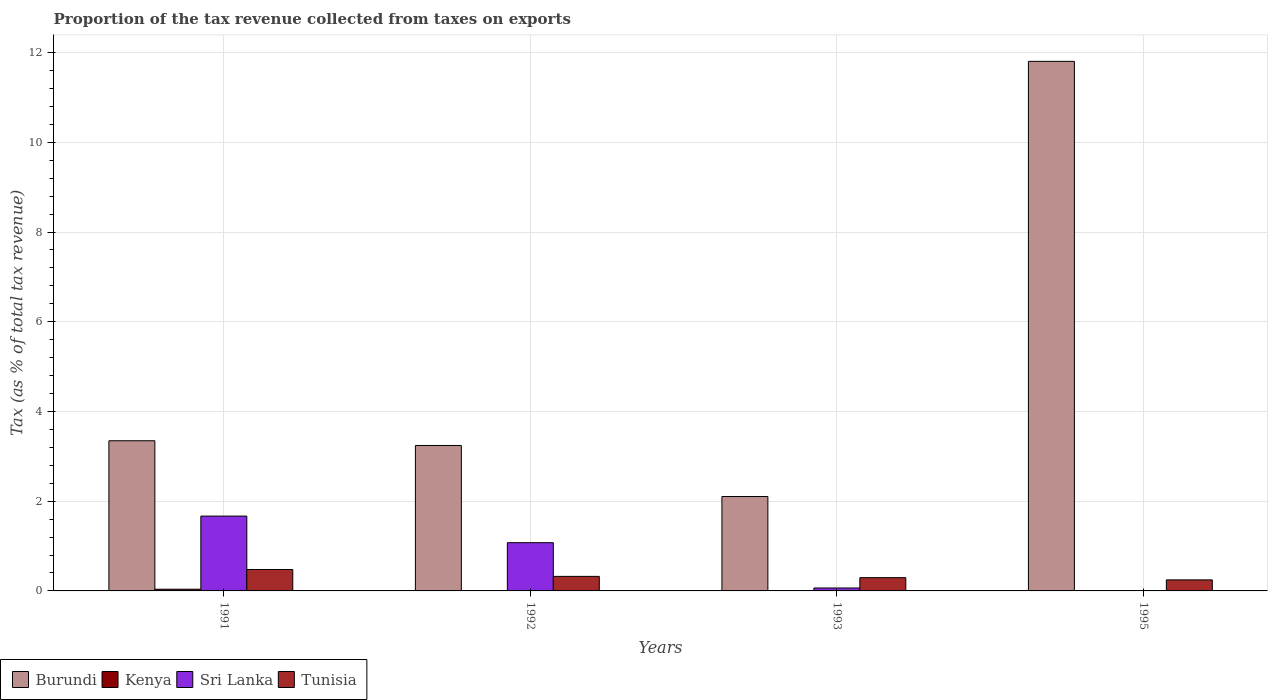How many different coloured bars are there?
Keep it short and to the point. 4. Are the number of bars per tick equal to the number of legend labels?
Provide a succinct answer. Yes. What is the label of the 1st group of bars from the left?
Keep it short and to the point. 1991. In how many cases, is the number of bars for a given year not equal to the number of legend labels?
Provide a short and direct response. 0. What is the proportion of the tax revenue collected in Burundi in 1991?
Your answer should be very brief. 3.35. Across all years, what is the maximum proportion of the tax revenue collected in Sri Lanka?
Your answer should be compact. 1.67. Across all years, what is the minimum proportion of the tax revenue collected in Kenya?
Your answer should be compact. 0. In which year was the proportion of the tax revenue collected in Sri Lanka minimum?
Your answer should be very brief. 1995. What is the total proportion of the tax revenue collected in Kenya in the graph?
Offer a very short reply. 0.05. What is the difference between the proportion of the tax revenue collected in Tunisia in 1993 and that in 1995?
Make the answer very short. 0.05. What is the difference between the proportion of the tax revenue collected in Kenya in 1992 and the proportion of the tax revenue collected in Burundi in 1993?
Offer a terse response. -2.1. What is the average proportion of the tax revenue collected in Burundi per year?
Give a very brief answer. 5.12. In the year 1995, what is the difference between the proportion of the tax revenue collected in Kenya and proportion of the tax revenue collected in Tunisia?
Offer a very short reply. -0.24. In how many years, is the proportion of the tax revenue collected in Sri Lanka greater than 8.4 %?
Your answer should be very brief. 0. What is the ratio of the proportion of the tax revenue collected in Tunisia in 1991 to that in 1995?
Your answer should be compact. 1.94. Is the proportion of the tax revenue collected in Kenya in 1992 less than that in 1993?
Give a very brief answer. No. What is the difference between the highest and the second highest proportion of the tax revenue collected in Tunisia?
Keep it short and to the point. 0.15. What is the difference between the highest and the lowest proportion of the tax revenue collected in Tunisia?
Offer a terse response. 0.23. Is the sum of the proportion of the tax revenue collected in Sri Lanka in 1992 and 1995 greater than the maximum proportion of the tax revenue collected in Burundi across all years?
Give a very brief answer. No. Is it the case that in every year, the sum of the proportion of the tax revenue collected in Sri Lanka and proportion of the tax revenue collected in Burundi is greater than the sum of proportion of the tax revenue collected in Tunisia and proportion of the tax revenue collected in Kenya?
Your answer should be very brief. Yes. What does the 1st bar from the left in 1991 represents?
Give a very brief answer. Burundi. What does the 1st bar from the right in 1995 represents?
Make the answer very short. Tunisia. Is it the case that in every year, the sum of the proportion of the tax revenue collected in Tunisia and proportion of the tax revenue collected in Sri Lanka is greater than the proportion of the tax revenue collected in Kenya?
Offer a very short reply. Yes. Are all the bars in the graph horizontal?
Provide a succinct answer. No. How many years are there in the graph?
Keep it short and to the point. 4. Does the graph contain grids?
Give a very brief answer. Yes. How are the legend labels stacked?
Keep it short and to the point. Horizontal. What is the title of the graph?
Your answer should be compact. Proportion of the tax revenue collected from taxes on exports. What is the label or title of the Y-axis?
Your response must be concise. Tax (as % of total tax revenue). What is the Tax (as % of total tax revenue) in Burundi in 1991?
Your response must be concise. 3.35. What is the Tax (as % of total tax revenue) in Kenya in 1991?
Offer a very short reply. 0.04. What is the Tax (as % of total tax revenue) in Sri Lanka in 1991?
Keep it short and to the point. 1.67. What is the Tax (as % of total tax revenue) of Tunisia in 1991?
Your answer should be compact. 0.48. What is the Tax (as % of total tax revenue) in Burundi in 1992?
Your answer should be very brief. 3.24. What is the Tax (as % of total tax revenue) in Kenya in 1992?
Your response must be concise. 0. What is the Tax (as % of total tax revenue) in Sri Lanka in 1992?
Make the answer very short. 1.08. What is the Tax (as % of total tax revenue) of Tunisia in 1992?
Your response must be concise. 0.32. What is the Tax (as % of total tax revenue) of Burundi in 1993?
Give a very brief answer. 2.1. What is the Tax (as % of total tax revenue) in Kenya in 1993?
Your answer should be very brief. 0. What is the Tax (as % of total tax revenue) of Sri Lanka in 1993?
Offer a terse response. 0.07. What is the Tax (as % of total tax revenue) in Tunisia in 1993?
Your answer should be very brief. 0.3. What is the Tax (as % of total tax revenue) in Burundi in 1995?
Your response must be concise. 11.8. What is the Tax (as % of total tax revenue) of Kenya in 1995?
Your response must be concise. 0. What is the Tax (as % of total tax revenue) of Sri Lanka in 1995?
Offer a very short reply. 0.01. What is the Tax (as % of total tax revenue) of Tunisia in 1995?
Offer a terse response. 0.25. Across all years, what is the maximum Tax (as % of total tax revenue) in Burundi?
Your answer should be very brief. 11.8. Across all years, what is the maximum Tax (as % of total tax revenue) in Kenya?
Your answer should be compact. 0.04. Across all years, what is the maximum Tax (as % of total tax revenue) in Sri Lanka?
Make the answer very short. 1.67. Across all years, what is the maximum Tax (as % of total tax revenue) of Tunisia?
Ensure brevity in your answer.  0.48. Across all years, what is the minimum Tax (as % of total tax revenue) in Burundi?
Keep it short and to the point. 2.1. Across all years, what is the minimum Tax (as % of total tax revenue) in Kenya?
Make the answer very short. 0. Across all years, what is the minimum Tax (as % of total tax revenue) of Sri Lanka?
Make the answer very short. 0.01. Across all years, what is the minimum Tax (as % of total tax revenue) of Tunisia?
Your answer should be very brief. 0.25. What is the total Tax (as % of total tax revenue) of Burundi in the graph?
Make the answer very short. 20.5. What is the total Tax (as % of total tax revenue) of Kenya in the graph?
Offer a terse response. 0.05. What is the total Tax (as % of total tax revenue) of Sri Lanka in the graph?
Provide a succinct answer. 2.82. What is the total Tax (as % of total tax revenue) of Tunisia in the graph?
Give a very brief answer. 1.34. What is the difference between the Tax (as % of total tax revenue) in Burundi in 1991 and that in 1992?
Offer a terse response. 0.11. What is the difference between the Tax (as % of total tax revenue) of Kenya in 1991 and that in 1992?
Offer a very short reply. 0.03. What is the difference between the Tax (as % of total tax revenue) of Sri Lanka in 1991 and that in 1992?
Offer a terse response. 0.59. What is the difference between the Tax (as % of total tax revenue) of Tunisia in 1991 and that in 1992?
Your answer should be very brief. 0.15. What is the difference between the Tax (as % of total tax revenue) in Burundi in 1991 and that in 1993?
Provide a succinct answer. 1.24. What is the difference between the Tax (as % of total tax revenue) in Kenya in 1991 and that in 1993?
Provide a short and direct response. 0.04. What is the difference between the Tax (as % of total tax revenue) of Sri Lanka in 1991 and that in 1993?
Give a very brief answer. 1.6. What is the difference between the Tax (as % of total tax revenue) of Tunisia in 1991 and that in 1993?
Make the answer very short. 0.18. What is the difference between the Tax (as % of total tax revenue) in Burundi in 1991 and that in 1995?
Offer a very short reply. -8.46. What is the difference between the Tax (as % of total tax revenue) in Kenya in 1991 and that in 1995?
Give a very brief answer. 0.03. What is the difference between the Tax (as % of total tax revenue) of Sri Lanka in 1991 and that in 1995?
Your response must be concise. 1.66. What is the difference between the Tax (as % of total tax revenue) of Tunisia in 1991 and that in 1995?
Offer a very short reply. 0.23. What is the difference between the Tax (as % of total tax revenue) in Burundi in 1992 and that in 1993?
Provide a succinct answer. 1.14. What is the difference between the Tax (as % of total tax revenue) of Kenya in 1992 and that in 1993?
Offer a terse response. 0. What is the difference between the Tax (as % of total tax revenue) of Tunisia in 1992 and that in 1993?
Provide a short and direct response. 0.03. What is the difference between the Tax (as % of total tax revenue) in Burundi in 1992 and that in 1995?
Your response must be concise. -8.56. What is the difference between the Tax (as % of total tax revenue) of Kenya in 1992 and that in 1995?
Keep it short and to the point. 0. What is the difference between the Tax (as % of total tax revenue) in Sri Lanka in 1992 and that in 1995?
Make the answer very short. 1.07. What is the difference between the Tax (as % of total tax revenue) in Tunisia in 1992 and that in 1995?
Provide a succinct answer. 0.08. What is the difference between the Tax (as % of total tax revenue) in Burundi in 1993 and that in 1995?
Keep it short and to the point. -9.7. What is the difference between the Tax (as % of total tax revenue) in Kenya in 1993 and that in 1995?
Give a very brief answer. -0. What is the difference between the Tax (as % of total tax revenue) in Sri Lanka in 1993 and that in 1995?
Offer a terse response. 0.06. What is the difference between the Tax (as % of total tax revenue) in Tunisia in 1993 and that in 1995?
Your answer should be compact. 0.05. What is the difference between the Tax (as % of total tax revenue) of Burundi in 1991 and the Tax (as % of total tax revenue) of Kenya in 1992?
Give a very brief answer. 3.34. What is the difference between the Tax (as % of total tax revenue) in Burundi in 1991 and the Tax (as % of total tax revenue) in Sri Lanka in 1992?
Keep it short and to the point. 2.27. What is the difference between the Tax (as % of total tax revenue) in Burundi in 1991 and the Tax (as % of total tax revenue) in Tunisia in 1992?
Offer a terse response. 3.02. What is the difference between the Tax (as % of total tax revenue) in Kenya in 1991 and the Tax (as % of total tax revenue) in Sri Lanka in 1992?
Give a very brief answer. -1.04. What is the difference between the Tax (as % of total tax revenue) of Kenya in 1991 and the Tax (as % of total tax revenue) of Tunisia in 1992?
Ensure brevity in your answer.  -0.29. What is the difference between the Tax (as % of total tax revenue) in Sri Lanka in 1991 and the Tax (as % of total tax revenue) in Tunisia in 1992?
Provide a succinct answer. 1.34. What is the difference between the Tax (as % of total tax revenue) of Burundi in 1991 and the Tax (as % of total tax revenue) of Kenya in 1993?
Make the answer very short. 3.35. What is the difference between the Tax (as % of total tax revenue) of Burundi in 1991 and the Tax (as % of total tax revenue) of Sri Lanka in 1993?
Make the answer very short. 3.28. What is the difference between the Tax (as % of total tax revenue) in Burundi in 1991 and the Tax (as % of total tax revenue) in Tunisia in 1993?
Provide a short and direct response. 3.05. What is the difference between the Tax (as % of total tax revenue) in Kenya in 1991 and the Tax (as % of total tax revenue) in Sri Lanka in 1993?
Your answer should be very brief. -0.03. What is the difference between the Tax (as % of total tax revenue) of Kenya in 1991 and the Tax (as % of total tax revenue) of Tunisia in 1993?
Offer a very short reply. -0.26. What is the difference between the Tax (as % of total tax revenue) of Sri Lanka in 1991 and the Tax (as % of total tax revenue) of Tunisia in 1993?
Offer a very short reply. 1.37. What is the difference between the Tax (as % of total tax revenue) of Burundi in 1991 and the Tax (as % of total tax revenue) of Kenya in 1995?
Your answer should be very brief. 3.34. What is the difference between the Tax (as % of total tax revenue) of Burundi in 1991 and the Tax (as % of total tax revenue) of Sri Lanka in 1995?
Make the answer very short. 3.34. What is the difference between the Tax (as % of total tax revenue) of Burundi in 1991 and the Tax (as % of total tax revenue) of Tunisia in 1995?
Ensure brevity in your answer.  3.1. What is the difference between the Tax (as % of total tax revenue) in Kenya in 1991 and the Tax (as % of total tax revenue) in Sri Lanka in 1995?
Provide a succinct answer. 0.03. What is the difference between the Tax (as % of total tax revenue) of Kenya in 1991 and the Tax (as % of total tax revenue) of Tunisia in 1995?
Ensure brevity in your answer.  -0.21. What is the difference between the Tax (as % of total tax revenue) of Sri Lanka in 1991 and the Tax (as % of total tax revenue) of Tunisia in 1995?
Give a very brief answer. 1.42. What is the difference between the Tax (as % of total tax revenue) of Burundi in 1992 and the Tax (as % of total tax revenue) of Kenya in 1993?
Give a very brief answer. 3.24. What is the difference between the Tax (as % of total tax revenue) in Burundi in 1992 and the Tax (as % of total tax revenue) in Sri Lanka in 1993?
Provide a succinct answer. 3.18. What is the difference between the Tax (as % of total tax revenue) in Burundi in 1992 and the Tax (as % of total tax revenue) in Tunisia in 1993?
Offer a terse response. 2.95. What is the difference between the Tax (as % of total tax revenue) in Kenya in 1992 and the Tax (as % of total tax revenue) in Sri Lanka in 1993?
Provide a short and direct response. -0.06. What is the difference between the Tax (as % of total tax revenue) in Kenya in 1992 and the Tax (as % of total tax revenue) in Tunisia in 1993?
Your response must be concise. -0.29. What is the difference between the Tax (as % of total tax revenue) of Sri Lanka in 1992 and the Tax (as % of total tax revenue) of Tunisia in 1993?
Provide a short and direct response. 0.78. What is the difference between the Tax (as % of total tax revenue) of Burundi in 1992 and the Tax (as % of total tax revenue) of Kenya in 1995?
Your answer should be very brief. 3.24. What is the difference between the Tax (as % of total tax revenue) in Burundi in 1992 and the Tax (as % of total tax revenue) in Sri Lanka in 1995?
Offer a very short reply. 3.23. What is the difference between the Tax (as % of total tax revenue) of Burundi in 1992 and the Tax (as % of total tax revenue) of Tunisia in 1995?
Your answer should be very brief. 3. What is the difference between the Tax (as % of total tax revenue) of Kenya in 1992 and the Tax (as % of total tax revenue) of Sri Lanka in 1995?
Offer a terse response. -0. What is the difference between the Tax (as % of total tax revenue) of Kenya in 1992 and the Tax (as % of total tax revenue) of Tunisia in 1995?
Give a very brief answer. -0.24. What is the difference between the Tax (as % of total tax revenue) in Sri Lanka in 1992 and the Tax (as % of total tax revenue) in Tunisia in 1995?
Offer a very short reply. 0.83. What is the difference between the Tax (as % of total tax revenue) in Burundi in 1993 and the Tax (as % of total tax revenue) in Kenya in 1995?
Your answer should be very brief. 2.1. What is the difference between the Tax (as % of total tax revenue) in Burundi in 1993 and the Tax (as % of total tax revenue) in Sri Lanka in 1995?
Keep it short and to the point. 2.1. What is the difference between the Tax (as % of total tax revenue) of Burundi in 1993 and the Tax (as % of total tax revenue) of Tunisia in 1995?
Your answer should be very brief. 1.86. What is the difference between the Tax (as % of total tax revenue) of Kenya in 1993 and the Tax (as % of total tax revenue) of Sri Lanka in 1995?
Make the answer very short. -0. What is the difference between the Tax (as % of total tax revenue) in Kenya in 1993 and the Tax (as % of total tax revenue) in Tunisia in 1995?
Keep it short and to the point. -0.24. What is the difference between the Tax (as % of total tax revenue) in Sri Lanka in 1993 and the Tax (as % of total tax revenue) in Tunisia in 1995?
Make the answer very short. -0.18. What is the average Tax (as % of total tax revenue) in Burundi per year?
Make the answer very short. 5.12. What is the average Tax (as % of total tax revenue) in Kenya per year?
Your answer should be compact. 0.01. What is the average Tax (as % of total tax revenue) in Sri Lanka per year?
Your answer should be very brief. 0.7. What is the average Tax (as % of total tax revenue) in Tunisia per year?
Make the answer very short. 0.34. In the year 1991, what is the difference between the Tax (as % of total tax revenue) in Burundi and Tax (as % of total tax revenue) in Kenya?
Your answer should be compact. 3.31. In the year 1991, what is the difference between the Tax (as % of total tax revenue) in Burundi and Tax (as % of total tax revenue) in Sri Lanka?
Offer a terse response. 1.68. In the year 1991, what is the difference between the Tax (as % of total tax revenue) of Burundi and Tax (as % of total tax revenue) of Tunisia?
Give a very brief answer. 2.87. In the year 1991, what is the difference between the Tax (as % of total tax revenue) of Kenya and Tax (as % of total tax revenue) of Sri Lanka?
Keep it short and to the point. -1.63. In the year 1991, what is the difference between the Tax (as % of total tax revenue) in Kenya and Tax (as % of total tax revenue) in Tunisia?
Your response must be concise. -0.44. In the year 1991, what is the difference between the Tax (as % of total tax revenue) in Sri Lanka and Tax (as % of total tax revenue) in Tunisia?
Your response must be concise. 1.19. In the year 1992, what is the difference between the Tax (as % of total tax revenue) in Burundi and Tax (as % of total tax revenue) in Kenya?
Give a very brief answer. 3.24. In the year 1992, what is the difference between the Tax (as % of total tax revenue) in Burundi and Tax (as % of total tax revenue) in Sri Lanka?
Your answer should be very brief. 2.17. In the year 1992, what is the difference between the Tax (as % of total tax revenue) of Burundi and Tax (as % of total tax revenue) of Tunisia?
Your answer should be compact. 2.92. In the year 1992, what is the difference between the Tax (as % of total tax revenue) of Kenya and Tax (as % of total tax revenue) of Sri Lanka?
Your answer should be compact. -1.07. In the year 1992, what is the difference between the Tax (as % of total tax revenue) in Kenya and Tax (as % of total tax revenue) in Tunisia?
Offer a terse response. -0.32. In the year 1992, what is the difference between the Tax (as % of total tax revenue) in Sri Lanka and Tax (as % of total tax revenue) in Tunisia?
Your response must be concise. 0.75. In the year 1993, what is the difference between the Tax (as % of total tax revenue) of Burundi and Tax (as % of total tax revenue) of Kenya?
Offer a very short reply. 2.1. In the year 1993, what is the difference between the Tax (as % of total tax revenue) in Burundi and Tax (as % of total tax revenue) in Sri Lanka?
Offer a terse response. 2.04. In the year 1993, what is the difference between the Tax (as % of total tax revenue) of Burundi and Tax (as % of total tax revenue) of Tunisia?
Your answer should be compact. 1.81. In the year 1993, what is the difference between the Tax (as % of total tax revenue) in Kenya and Tax (as % of total tax revenue) in Sri Lanka?
Your answer should be compact. -0.06. In the year 1993, what is the difference between the Tax (as % of total tax revenue) of Kenya and Tax (as % of total tax revenue) of Tunisia?
Your answer should be very brief. -0.29. In the year 1993, what is the difference between the Tax (as % of total tax revenue) in Sri Lanka and Tax (as % of total tax revenue) in Tunisia?
Your answer should be very brief. -0.23. In the year 1995, what is the difference between the Tax (as % of total tax revenue) in Burundi and Tax (as % of total tax revenue) in Kenya?
Keep it short and to the point. 11.8. In the year 1995, what is the difference between the Tax (as % of total tax revenue) in Burundi and Tax (as % of total tax revenue) in Sri Lanka?
Your answer should be very brief. 11.8. In the year 1995, what is the difference between the Tax (as % of total tax revenue) of Burundi and Tax (as % of total tax revenue) of Tunisia?
Provide a short and direct response. 11.56. In the year 1995, what is the difference between the Tax (as % of total tax revenue) of Kenya and Tax (as % of total tax revenue) of Sri Lanka?
Make the answer very short. -0. In the year 1995, what is the difference between the Tax (as % of total tax revenue) in Kenya and Tax (as % of total tax revenue) in Tunisia?
Make the answer very short. -0.24. In the year 1995, what is the difference between the Tax (as % of total tax revenue) of Sri Lanka and Tax (as % of total tax revenue) of Tunisia?
Offer a terse response. -0.24. What is the ratio of the Tax (as % of total tax revenue) of Burundi in 1991 to that in 1992?
Keep it short and to the point. 1.03. What is the ratio of the Tax (as % of total tax revenue) in Kenya in 1991 to that in 1992?
Provide a short and direct response. 9.24. What is the ratio of the Tax (as % of total tax revenue) of Sri Lanka in 1991 to that in 1992?
Provide a short and direct response. 1.55. What is the ratio of the Tax (as % of total tax revenue) in Tunisia in 1991 to that in 1992?
Make the answer very short. 1.47. What is the ratio of the Tax (as % of total tax revenue) of Burundi in 1991 to that in 1993?
Offer a very short reply. 1.59. What is the ratio of the Tax (as % of total tax revenue) in Kenya in 1991 to that in 1993?
Your answer should be compact. 18.95. What is the ratio of the Tax (as % of total tax revenue) in Sri Lanka in 1991 to that in 1993?
Your answer should be very brief. 25.54. What is the ratio of the Tax (as % of total tax revenue) in Tunisia in 1991 to that in 1993?
Provide a succinct answer. 1.62. What is the ratio of the Tax (as % of total tax revenue) in Burundi in 1991 to that in 1995?
Your answer should be very brief. 0.28. What is the ratio of the Tax (as % of total tax revenue) of Kenya in 1991 to that in 1995?
Offer a very short reply. 12.06. What is the ratio of the Tax (as % of total tax revenue) in Sri Lanka in 1991 to that in 1995?
Provide a short and direct response. 247.19. What is the ratio of the Tax (as % of total tax revenue) of Tunisia in 1991 to that in 1995?
Your response must be concise. 1.94. What is the ratio of the Tax (as % of total tax revenue) in Burundi in 1992 to that in 1993?
Offer a very short reply. 1.54. What is the ratio of the Tax (as % of total tax revenue) in Kenya in 1992 to that in 1993?
Offer a terse response. 2.05. What is the ratio of the Tax (as % of total tax revenue) of Sri Lanka in 1992 to that in 1993?
Offer a very short reply. 16.46. What is the ratio of the Tax (as % of total tax revenue) of Tunisia in 1992 to that in 1993?
Keep it short and to the point. 1.1. What is the ratio of the Tax (as % of total tax revenue) of Burundi in 1992 to that in 1995?
Provide a short and direct response. 0.27. What is the ratio of the Tax (as % of total tax revenue) in Kenya in 1992 to that in 1995?
Ensure brevity in your answer.  1.31. What is the ratio of the Tax (as % of total tax revenue) in Sri Lanka in 1992 to that in 1995?
Give a very brief answer. 159.33. What is the ratio of the Tax (as % of total tax revenue) in Tunisia in 1992 to that in 1995?
Give a very brief answer. 1.32. What is the ratio of the Tax (as % of total tax revenue) in Burundi in 1993 to that in 1995?
Keep it short and to the point. 0.18. What is the ratio of the Tax (as % of total tax revenue) of Kenya in 1993 to that in 1995?
Ensure brevity in your answer.  0.64. What is the ratio of the Tax (as % of total tax revenue) of Sri Lanka in 1993 to that in 1995?
Offer a terse response. 9.68. What is the ratio of the Tax (as % of total tax revenue) of Tunisia in 1993 to that in 1995?
Your answer should be very brief. 1.2. What is the difference between the highest and the second highest Tax (as % of total tax revenue) of Burundi?
Ensure brevity in your answer.  8.46. What is the difference between the highest and the second highest Tax (as % of total tax revenue) of Kenya?
Provide a short and direct response. 0.03. What is the difference between the highest and the second highest Tax (as % of total tax revenue) in Sri Lanka?
Offer a terse response. 0.59. What is the difference between the highest and the second highest Tax (as % of total tax revenue) in Tunisia?
Provide a short and direct response. 0.15. What is the difference between the highest and the lowest Tax (as % of total tax revenue) in Burundi?
Ensure brevity in your answer.  9.7. What is the difference between the highest and the lowest Tax (as % of total tax revenue) of Kenya?
Provide a short and direct response. 0.04. What is the difference between the highest and the lowest Tax (as % of total tax revenue) in Sri Lanka?
Provide a short and direct response. 1.66. What is the difference between the highest and the lowest Tax (as % of total tax revenue) in Tunisia?
Make the answer very short. 0.23. 